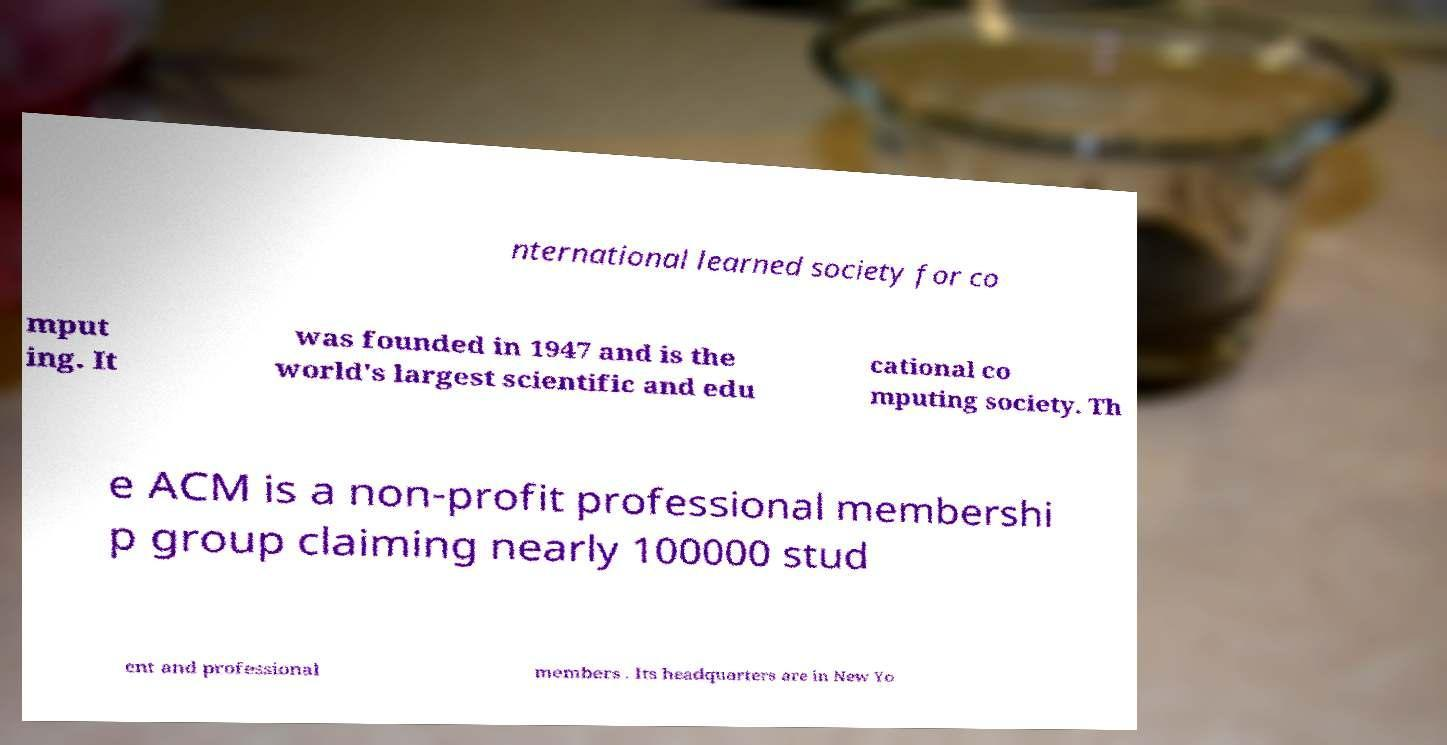Could you assist in decoding the text presented in this image and type it out clearly? nternational learned society for co mput ing. It was founded in 1947 and is the world's largest scientific and edu cational co mputing society. Th e ACM is a non-profit professional membershi p group claiming nearly 100000 stud ent and professional members . Its headquarters are in New Yo 